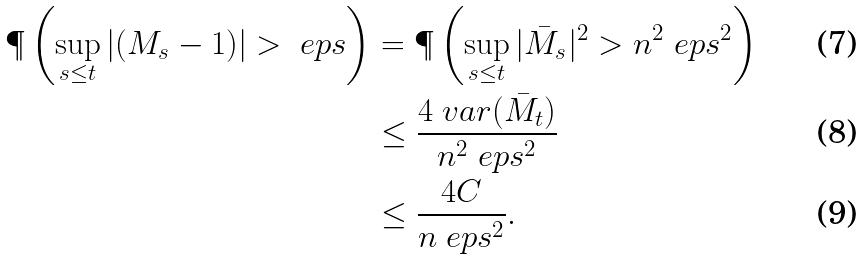Convert formula to latex. <formula><loc_0><loc_0><loc_500><loc_500>\P \left ( \sup _ { s \leq t } | ( M _ { s } - 1 ) | > \ e p s \right ) & = \P \left ( \sup _ { s \leq t } | \bar { M } _ { s } | ^ { 2 } > n ^ { 2 } \ e p s ^ { 2 } \right ) \\ & \leq \frac { 4 \ v a r ( \bar { M } _ { t } ) } { n ^ { 2 } \ e p s ^ { 2 } } \\ & \leq \frac { 4 C } { n \ e p s ^ { 2 } } .</formula> 